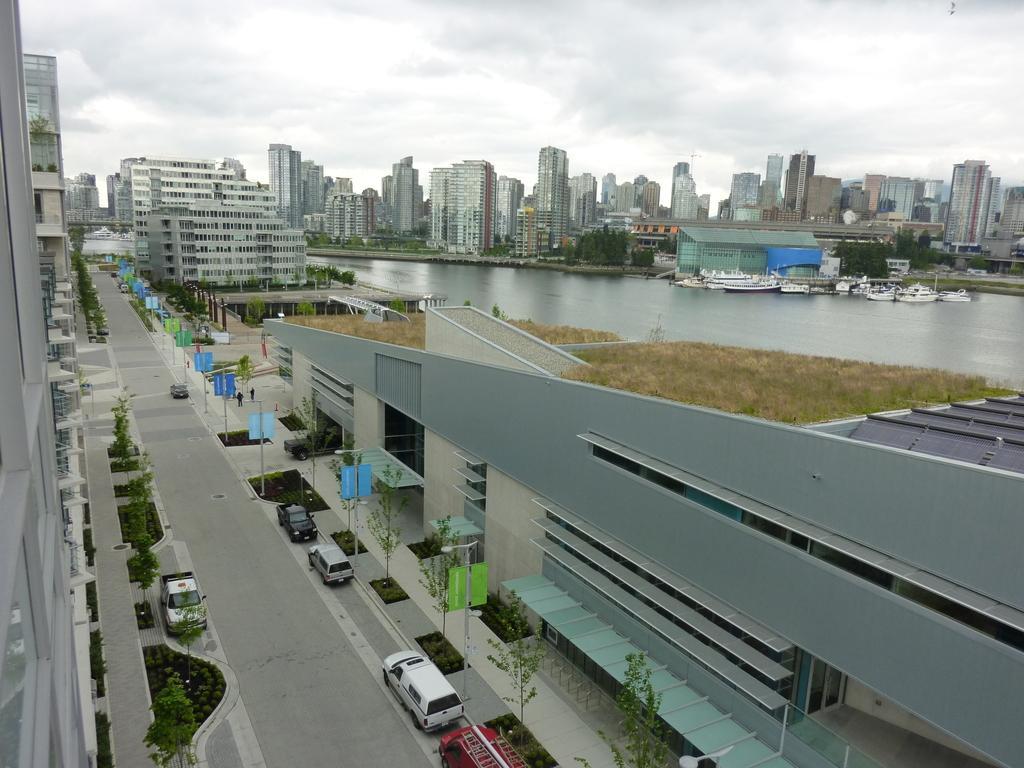Could you give a brief overview of what you see in this image? In this image I can see few vehicles on the road and I can see few plants and trees in green color, few boards attached to the poles, buildings. In the background I can see few ships on the water and the sky is in white color. 